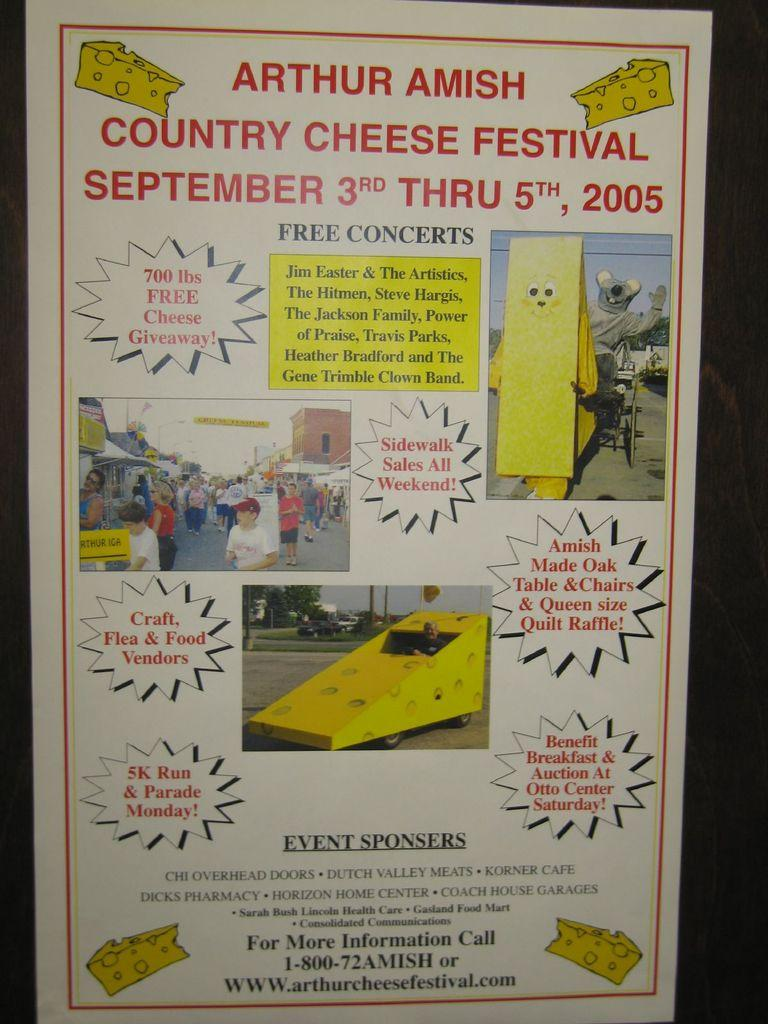What is present in the image that contains information or visuals? There is a poster in the image. What can be found on the poster? The poster contains text and images. What type of images are depicted on the poster? The images within the poster depict persons. What type of polish is being applied to the snail in the image? There is no snail or polish present in the image; it only contains a poster with text and images of persons. 